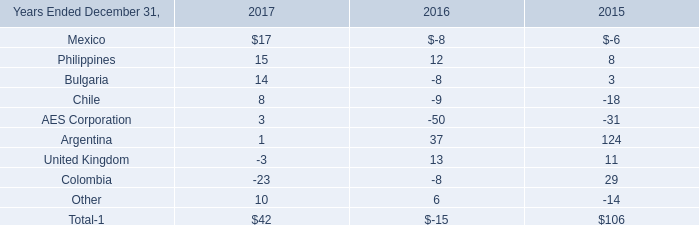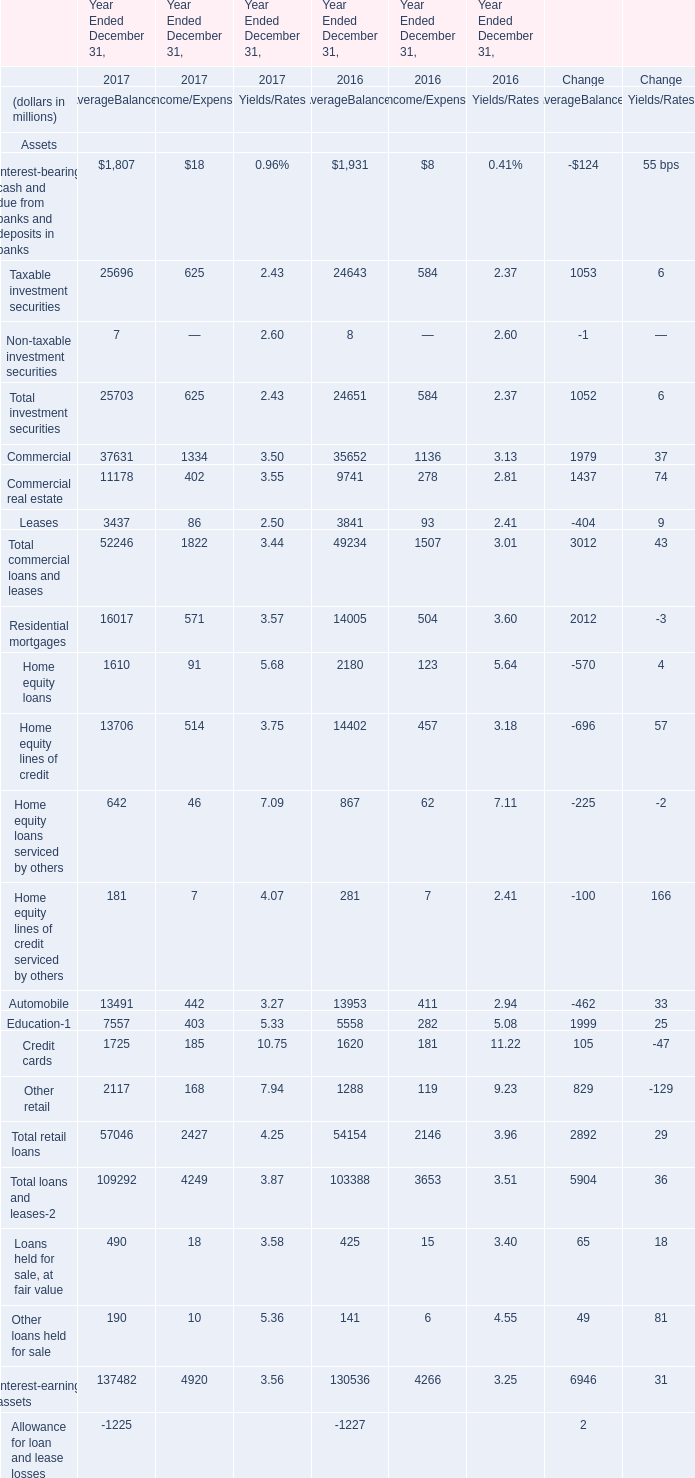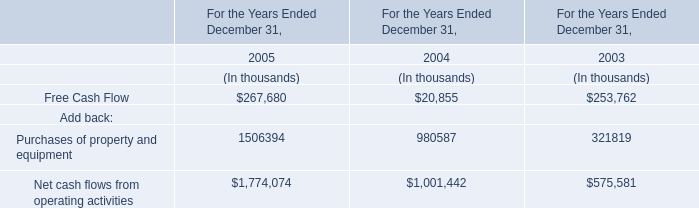Which year is Total investment securities for AverageBalances the most? 
Answer: 2017. 